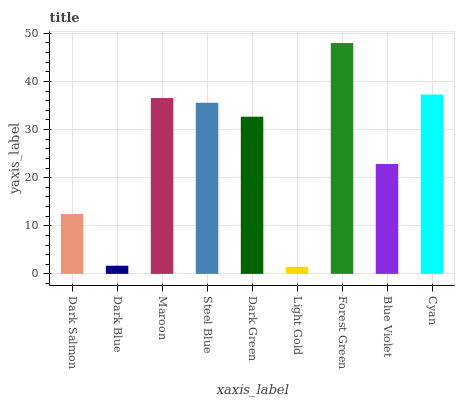Is Light Gold the minimum?
Answer yes or no. Yes. Is Forest Green the maximum?
Answer yes or no. Yes. Is Dark Blue the minimum?
Answer yes or no. No. Is Dark Blue the maximum?
Answer yes or no. No. Is Dark Salmon greater than Dark Blue?
Answer yes or no. Yes. Is Dark Blue less than Dark Salmon?
Answer yes or no. Yes. Is Dark Blue greater than Dark Salmon?
Answer yes or no. No. Is Dark Salmon less than Dark Blue?
Answer yes or no. No. Is Dark Green the high median?
Answer yes or no. Yes. Is Dark Green the low median?
Answer yes or no. Yes. Is Cyan the high median?
Answer yes or no. No. Is Light Gold the low median?
Answer yes or no. No. 